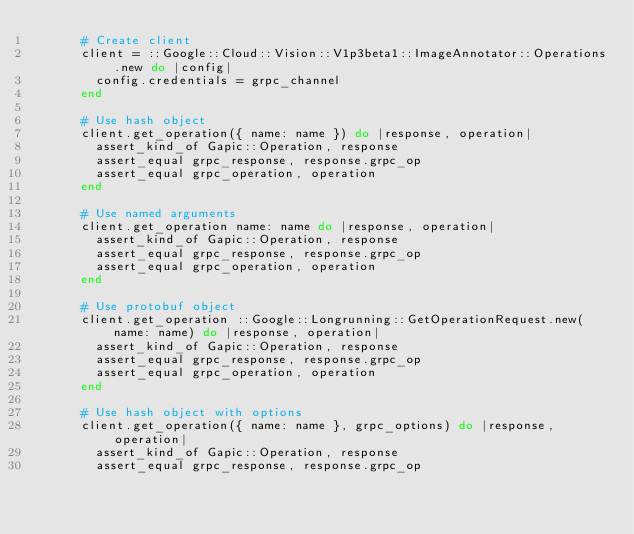Convert code to text. <code><loc_0><loc_0><loc_500><loc_500><_Ruby_>      # Create client
      client = ::Google::Cloud::Vision::V1p3beta1::ImageAnnotator::Operations.new do |config|
        config.credentials = grpc_channel
      end

      # Use hash object
      client.get_operation({ name: name }) do |response, operation|
        assert_kind_of Gapic::Operation, response
        assert_equal grpc_response, response.grpc_op
        assert_equal grpc_operation, operation
      end

      # Use named arguments
      client.get_operation name: name do |response, operation|
        assert_kind_of Gapic::Operation, response
        assert_equal grpc_response, response.grpc_op
        assert_equal grpc_operation, operation
      end

      # Use protobuf object
      client.get_operation ::Google::Longrunning::GetOperationRequest.new(name: name) do |response, operation|
        assert_kind_of Gapic::Operation, response
        assert_equal grpc_response, response.grpc_op
        assert_equal grpc_operation, operation
      end

      # Use hash object with options
      client.get_operation({ name: name }, grpc_options) do |response, operation|
        assert_kind_of Gapic::Operation, response
        assert_equal grpc_response, response.grpc_op</code> 